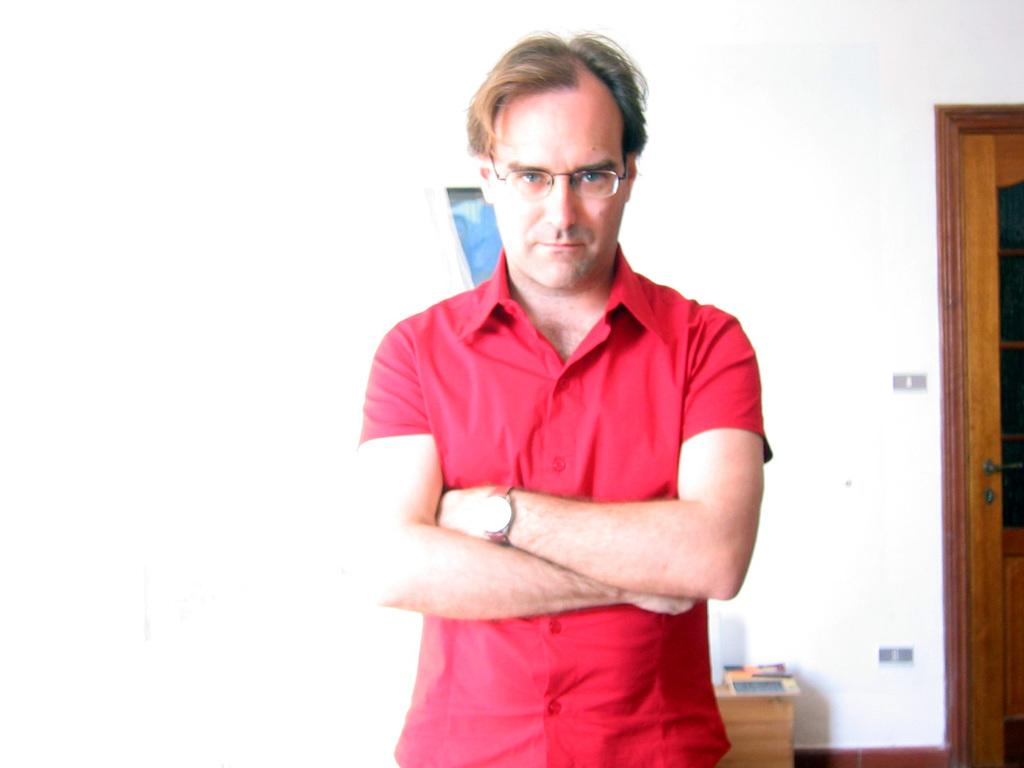Who is present in the image? There is a man in the image. What is the man wearing? The man is wearing spectacles. What is the man's posture in the image? The man is standing. What piece of furniture can be seen in the image? There is a table in the image. What is on top of the table? There is an object on the table. Where is the door located in the image? The door is on the right side of the image. How does the man increase the volume of the horn in the image? There is no horn present in the image, so it is not possible to increase its volume. 